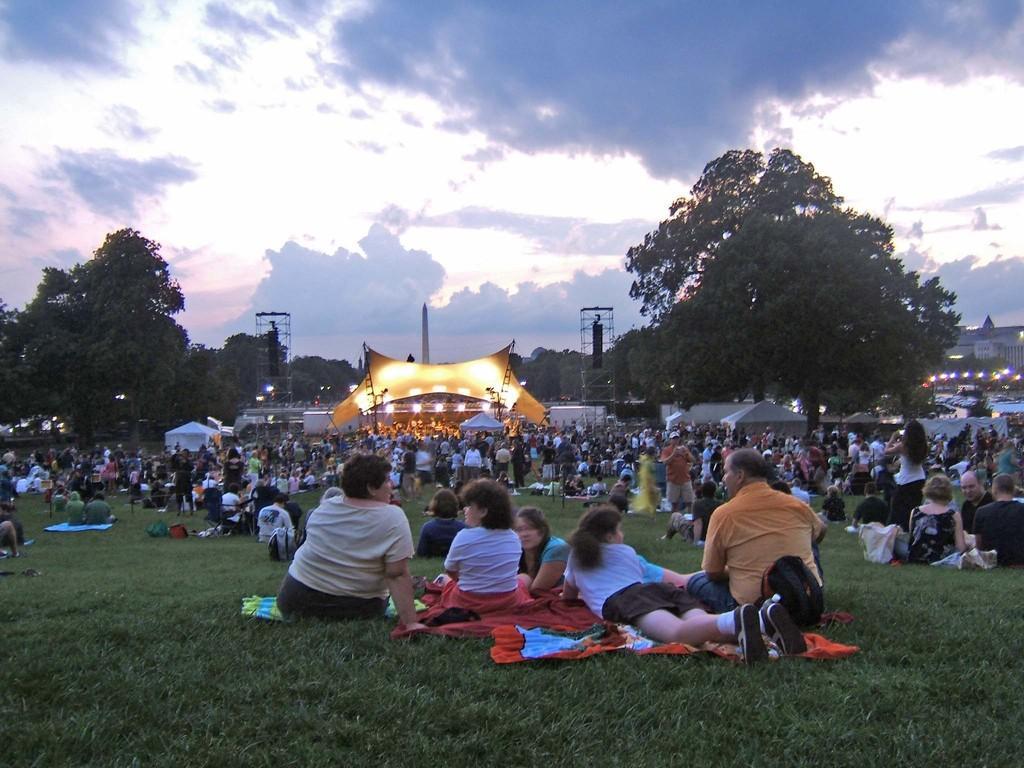Describe this image in one or two sentences. In this image I can see an open grass ground and on it I can see number of people. In the background I can see number of trees, a yellow colour thing, number of lights, clouds and the sky. 